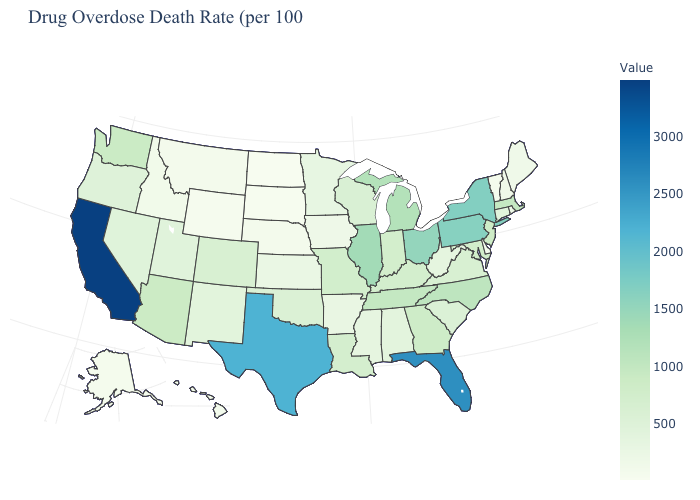Does Delaware have the lowest value in the South?
Give a very brief answer. Yes. Among the states that border Ohio , does West Virginia have the highest value?
Short answer required. No. Among the states that border Kansas , does Nebraska have the lowest value?
Short answer required. Yes. Does Alabama have a lower value than South Dakota?
Short answer required. No. Does Utah have a lower value than Arizona?
Concise answer only. Yes. Among the states that border Virginia , does North Carolina have the highest value?
Keep it brief. Yes. 